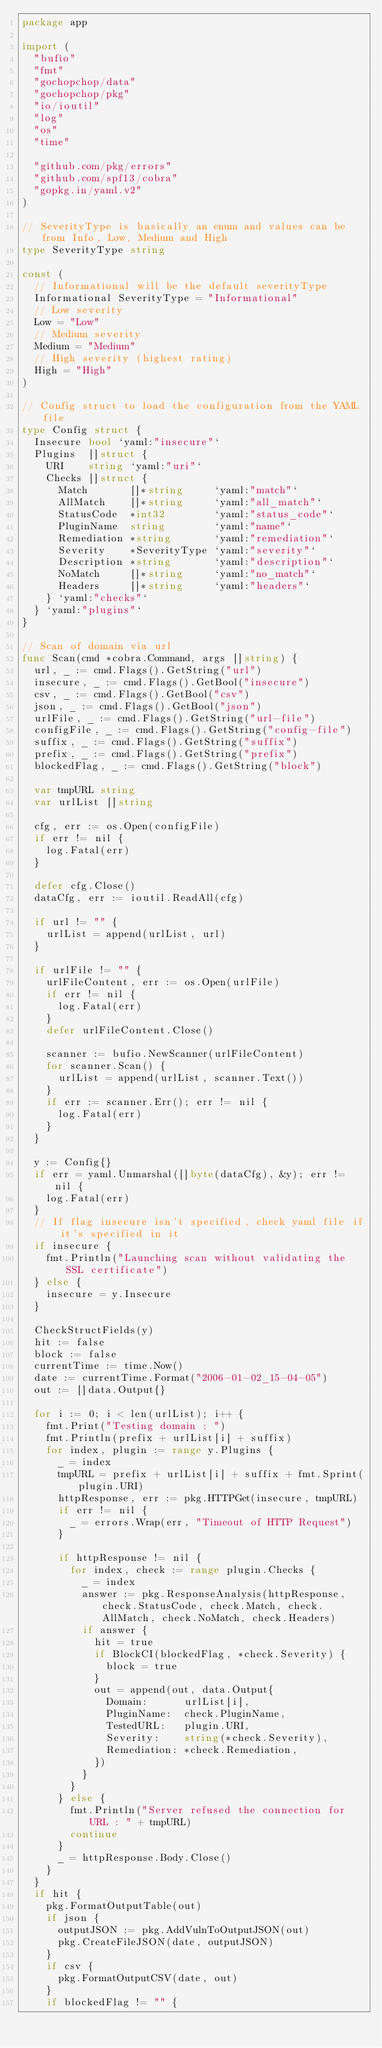Convert code to text. <code><loc_0><loc_0><loc_500><loc_500><_Go_>package app

import (
	"bufio"
	"fmt"
	"gochopchop/data"
	"gochopchop/pkg"
	"io/ioutil"
	"log"
	"os"
	"time"

	"github.com/pkg/errors"
	"github.com/spf13/cobra"
	"gopkg.in/yaml.v2"
)

// SeverityType is basically an enum and values can be from Info, Low, Medium and High
type SeverityType string

const (
	// Informational will be the default severityType
	Informational SeverityType = "Informational"
	// Low severity
	Low = "Low"
	// Medium severity
	Medium = "Medium"
	// High severity (highest rating)
	High = "High"
)

// Config struct to load the configuration from the YAML file
type Config struct {
	Insecure bool `yaml:"insecure"`
	Plugins  []struct {
		URI    string `yaml:"uri"`
		Checks []struct {
			Match       []*string     `yaml:"match"`
			AllMatch    []*string     `yaml:"all_match"`
			StatusCode  *int32        `yaml:"status_code"`
			PluginName  string        `yaml:"name"`
			Remediation *string       `yaml:"remediation"`
			Severity    *SeverityType `yaml:"severity"`
			Description *string       `yaml:"description"`
			NoMatch     []*string     `yaml:"no_match"`
			Headers     []*string     `yaml:"headers"`
		} `yaml:"checks"`
	} `yaml:"plugins"`
}

// Scan of domain via url
func Scan(cmd *cobra.Command, args []string) {
	url, _ := cmd.Flags().GetString("url")
	insecure, _ := cmd.Flags().GetBool("insecure")
	csv, _ := cmd.Flags().GetBool("csv")
	json, _ := cmd.Flags().GetBool("json")
	urlFile, _ := cmd.Flags().GetString("url-file")
	configFile, _ := cmd.Flags().GetString("config-file")
	suffix, _ := cmd.Flags().GetString("suffix")
	prefix, _ := cmd.Flags().GetString("prefix")
	blockedFlag, _ := cmd.Flags().GetString("block")

	var tmpURL string
	var urlList []string

	cfg, err := os.Open(configFile)
	if err != nil {
		log.Fatal(err)
	}

	defer cfg.Close()
	dataCfg, err := ioutil.ReadAll(cfg)

	if url != "" {
		urlList = append(urlList, url)
	}

	if urlFile != "" {
		urlFileContent, err := os.Open(urlFile)
		if err != nil {
			log.Fatal(err)
		}
		defer urlFileContent.Close()

		scanner := bufio.NewScanner(urlFileContent)
		for scanner.Scan() {
			urlList = append(urlList, scanner.Text())
		}
		if err := scanner.Err(); err != nil {
			log.Fatal(err)
		}
	}

	y := Config{}
	if err = yaml.Unmarshal([]byte(dataCfg), &y); err != nil {
		log.Fatal(err)
	}
	// If flag insecure isn't specified, check yaml file if it's specified in it
	if insecure {
		fmt.Println("Launching scan without validating the SSL certificate")
	} else {
		insecure = y.Insecure
	}

	CheckStructFields(y)
	hit := false
	block := false
	currentTime := time.Now()
	date := currentTime.Format("2006-01-02_15-04-05")
	out := []data.Output{}

	for i := 0; i < len(urlList); i++ {
		fmt.Print("Testing domain : ")
		fmt.Println(prefix + urlList[i] + suffix)
		for index, plugin := range y.Plugins {
			_ = index
			tmpURL = prefix + urlList[i] + suffix + fmt.Sprint(plugin.URI)
			httpResponse, err := pkg.HTTPGet(insecure, tmpURL)
			if err != nil {
				_ = errors.Wrap(err, "Timeout of HTTP Request")
			}

			if httpResponse != nil {
				for index, check := range plugin.Checks {
					_ = index
					answer := pkg.ResponseAnalysis(httpResponse, check.StatusCode, check.Match, check.AllMatch, check.NoMatch, check.Headers)
					if answer {
						hit = true
						if BlockCI(blockedFlag, *check.Severity) {
							block = true
						}
						out = append(out, data.Output{
							Domain:      urlList[i],
							PluginName:  check.PluginName,
							TestedURL:   plugin.URI,
							Severity:    string(*check.Severity),
							Remediation: *check.Remediation,
						})
					}
				}
			} else {
				fmt.Println("Server refused the connection for URL : " + tmpURL)
				continue
			}
			_ = httpResponse.Body.Close()
		}
	}
	if hit {
		pkg.FormatOutputTable(out)
		if json {
			outputJSON := pkg.AddVulnToOutputJSON(out)
			pkg.CreateFileJSON(date, outputJSON)
		}
		if csv {
			pkg.FormatOutputCSV(date, out)
		}
		if blockedFlag != "" {</code> 